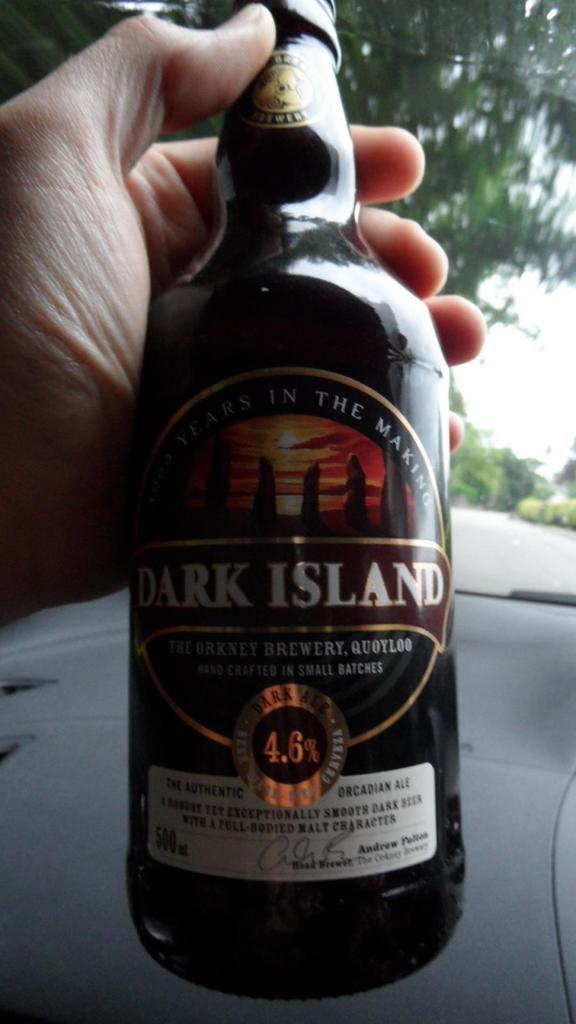What brand name is this drink?
Provide a short and direct response. Dark island. Who brews this?
Offer a terse response. Dark island. 